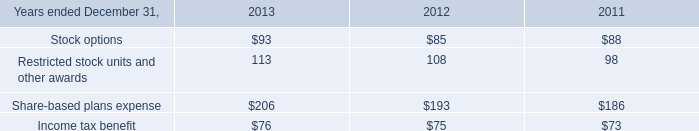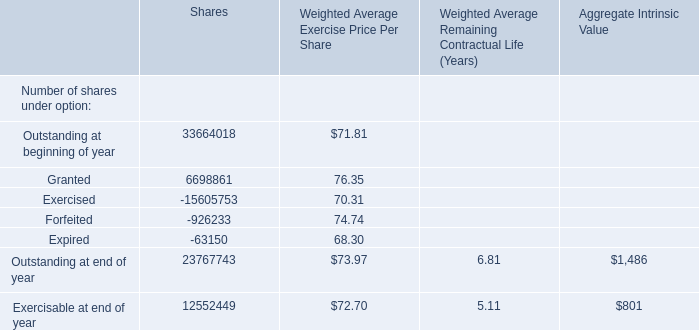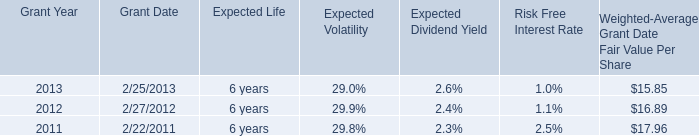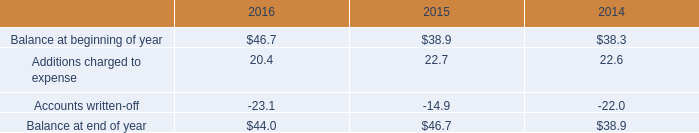What was the average value of the Restricted stock units and other awards in the years where Stock options is positive? 
Computations: (((113 + 108) + 98) / 3)
Answer: 106.33333. 